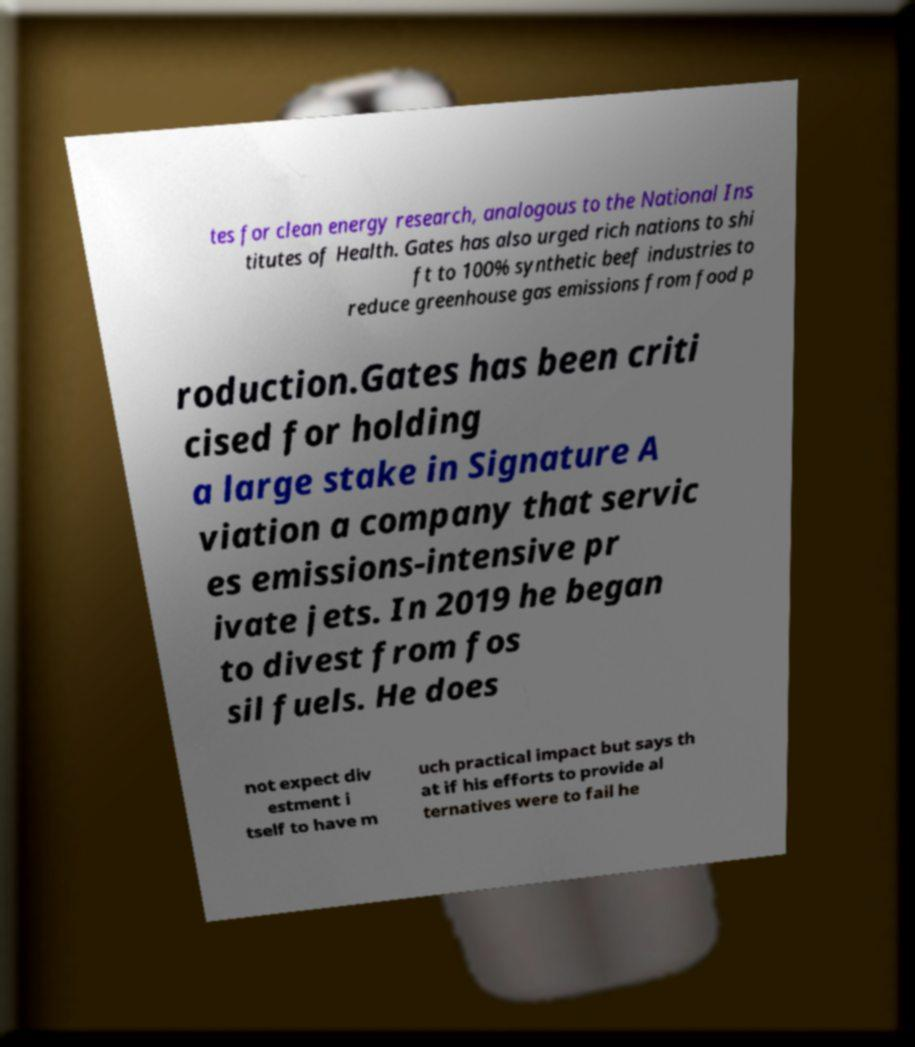What messages or text are displayed in this image? I need them in a readable, typed format. tes for clean energy research, analogous to the National Ins titutes of Health. Gates has also urged rich nations to shi ft to 100% synthetic beef industries to reduce greenhouse gas emissions from food p roduction.Gates has been criti cised for holding a large stake in Signature A viation a company that servic es emissions-intensive pr ivate jets. In 2019 he began to divest from fos sil fuels. He does not expect div estment i tself to have m uch practical impact but says th at if his efforts to provide al ternatives were to fail he 